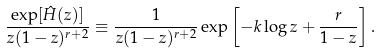Convert formula to latex. <formula><loc_0><loc_0><loc_500><loc_500>\frac { \exp [ \hat { H } ( z ) ] } { z ( 1 - z ) ^ { r + 2 } } \equiv \frac { 1 } { z ( 1 - z ) ^ { r + 2 } } \exp \left [ - k \log z + \frac { r } { 1 - z } \right ] .</formula> 